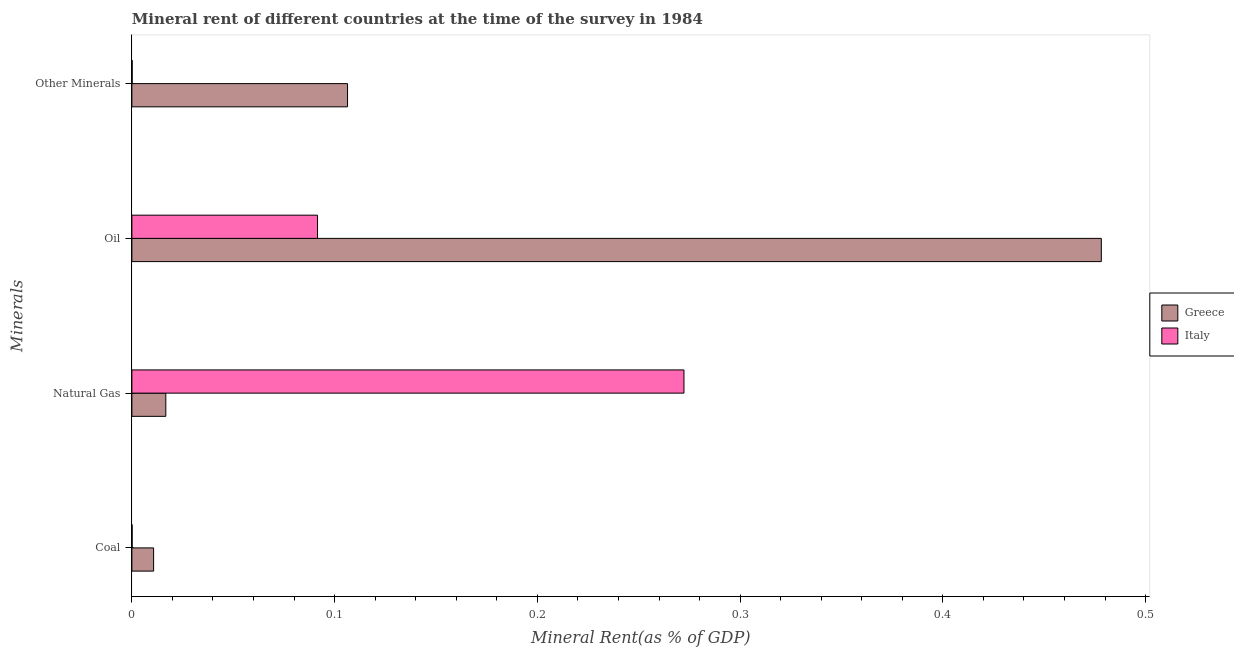How many different coloured bars are there?
Your response must be concise. 2. Are the number of bars per tick equal to the number of legend labels?
Your answer should be compact. Yes. Are the number of bars on each tick of the Y-axis equal?
Provide a short and direct response. Yes. How many bars are there on the 3rd tick from the bottom?
Your answer should be compact. 2. What is the label of the 1st group of bars from the top?
Offer a terse response. Other Minerals. What is the  rent of other minerals in Italy?
Provide a succinct answer. 0. Across all countries, what is the maximum oil rent?
Make the answer very short. 0.48. Across all countries, what is the minimum coal rent?
Your response must be concise. 0. In which country was the natural gas rent maximum?
Keep it short and to the point. Italy. What is the total oil rent in the graph?
Offer a very short reply. 0.57. What is the difference between the  rent of other minerals in Italy and that in Greece?
Offer a terse response. -0.11. What is the difference between the natural gas rent in Greece and the oil rent in Italy?
Your answer should be compact. -0.07. What is the average  rent of other minerals per country?
Provide a succinct answer. 0.05. What is the difference between the coal rent and  rent of other minerals in Italy?
Your answer should be very brief. -3.1037804786455015e-5. In how many countries, is the natural gas rent greater than 0.26 %?
Your answer should be very brief. 1. What is the ratio of the oil rent in Italy to that in Greece?
Provide a short and direct response. 0.19. Is the difference between the natural gas rent in Greece and Italy greater than the difference between the  rent of other minerals in Greece and Italy?
Offer a very short reply. No. What is the difference between the highest and the second highest coal rent?
Offer a terse response. 0.01. What is the difference between the highest and the lowest coal rent?
Offer a terse response. 0.01. Is the sum of the coal rent in Italy and Greece greater than the maximum oil rent across all countries?
Make the answer very short. No. What does the 1st bar from the top in Other Minerals represents?
Give a very brief answer. Italy. What does the 2nd bar from the bottom in Natural Gas represents?
Offer a terse response. Italy. Are all the bars in the graph horizontal?
Make the answer very short. Yes. How many countries are there in the graph?
Offer a very short reply. 2. Does the graph contain grids?
Your answer should be compact. No. How many legend labels are there?
Make the answer very short. 2. How are the legend labels stacked?
Make the answer very short. Vertical. What is the title of the graph?
Your response must be concise. Mineral rent of different countries at the time of the survey in 1984. Does "Mexico" appear as one of the legend labels in the graph?
Keep it short and to the point. No. What is the label or title of the X-axis?
Offer a very short reply. Mineral Rent(as % of GDP). What is the label or title of the Y-axis?
Offer a very short reply. Minerals. What is the Mineral Rent(as % of GDP) in Greece in Coal?
Keep it short and to the point. 0.01. What is the Mineral Rent(as % of GDP) in Italy in Coal?
Your answer should be very brief. 0. What is the Mineral Rent(as % of GDP) of Greece in Natural Gas?
Offer a terse response. 0.02. What is the Mineral Rent(as % of GDP) in Italy in Natural Gas?
Give a very brief answer. 0.27. What is the Mineral Rent(as % of GDP) of Greece in Oil?
Keep it short and to the point. 0.48. What is the Mineral Rent(as % of GDP) in Italy in Oil?
Offer a terse response. 0.09. What is the Mineral Rent(as % of GDP) of Greece in Other Minerals?
Offer a terse response. 0.11. What is the Mineral Rent(as % of GDP) in Italy in Other Minerals?
Provide a succinct answer. 0. Across all Minerals, what is the maximum Mineral Rent(as % of GDP) of Greece?
Ensure brevity in your answer.  0.48. Across all Minerals, what is the maximum Mineral Rent(as % of GDP) of Italy?
Your response must be concise. 0.27. Across all Minerals, what is the minimum Mineral Rent(as % of GDP) of Greece?
Your answer should be very brief. 0.01. Across all Minerals, what is the minimum Mineral Rent(as % of GDP) in Italy?
Keep it short and to the point. 0. What is the total Mineral Rent(as % of GDP) in Greece in the graph?
Offer a very short reply. 0.61. What is the total Mineral Rent(as % of GDP) of Italy in the graph?
Keep it short and to the point. 0.36. What is the difference between the Mineral Rent(as % of GDP) of Greece in Coal and that in Natural Gas?
Ensure brevity in your answer.  -0.01. What is the difference between the Mineral Rent(as % of GDP) in Italy in Coal and that in Natural Gas?
Your answer should be very brief. -0.27. What is the difference between the Mineral Rent(as % of GDP) in Greece in Coal and that in Oil?
Your answer should be very brief. -0.47. What is the difference between the Mineral Rent(as % of GDP) of Italy in Coal and that in Oil?
Your answer should be very brief. -0.09. What is the difference between the Mineral Rent(as % of GDP) of Greece in Coal and that in Other Minerals?
Your answer should be compact. -0.1. What is the difference between the Mineral Rent(as % of GDP) in Greece in Natural Gas and that in Oil?
Provide a short and direct response. -0.46. What is the difference between the Mineral Rent(as % of GDP) of Italy in Natural Gas and that in Oil?
Provide a succinct answer. 0.18. What is the difference between the Mineral Rent(as % of GDP) of Greece in Natural Gas and that in Other Minerals?
Your answer should be very brief. -0.09. What is the difference between the Mineral Rent(as % of GDP) of Italy in Natural Gas and that in Other Minerals?
Give a very brief answer. 0.27. What is the difference between the Mineral Rent(as % of GDP) of Greece in Oil and that in Other Minerals?
Offer a very short reply. 0.37. What is the difference between the Mineral Rent(as % of GDP) of Italy in Oil and that in Other Minerals?
Offer a terse response. 0.09. What is the difference between the Mineral Rent(as % of GDP) in Greece in Coal and the Mineral Rent(as % of GDP) in Italy in Natural Gas?
Provide a short and direct response. -0.26. What is the difference between the Mineral Rent(as % of GDP) in Greece in Coal and the Mineral Rent(as % of GDP) in Italy in Oil?
Ensure brevity in your answer.  -0.08. What is the difference between the Mineral Rent(as % of GDP) in Greece in Coal and the Mineral Rent(as % of GDP) in Italy in Other Minerals?
Provide a short and direct response. 0.01. What is the difference between the Mineral Rent(as % of GDP) in Greece in Natural Gas and the Mineral Rent(as % of GDP) in Italy in Oil?
Your answer should be compact. -0.07. What is the difference between the Mineral Rent(as % of GDP) in Greece in Natural Gas and the Mineral Rent(as % of GDP) in Italy in Other Minerals?
Provide a short and direct response. 0.02. What is the difference between the Mineral Rent(as % of GDP) of Greece in Oil and the Mineral Rent(as % of GDP) of Italy in Other Minerals?
Offer a very short reply. 0.48. What is the average Mineral Rent(as % of GDP) of Greece per Minerals?
Keep it short and to the point. 0.15. What is the average Mineral Rent(as % of GDP) of Italy per Minerals?
Your answer should be compact. 0.09. What is the difference between the Mineral Rent(as % of GDP) of Greece and Mineral Rent(as % of GDP) of Italy in Coal?
Make the answer very short. 0.01. What is the difference between the Mineral Rent(as % of GDP) in Greece and Mineral Rent(as % of GDP) in Italy in Natural Gas?
Make the answer very short. -0.26. What is the difference between the Mineral Rent(as % of GDP) of Greece and Mineral Rent(as % of GDP) of Italy in Oil?
Make the answer very short. 0.39. What is the difference between the Mineral Rent(as % of GDP) in Greece and Mineral Rent(as % of GDP) in Italy in Other Minerals?
Give a very brief answer. 0.11. What is the ratio of the Mineral Rent(as % of GDP) of Greece in Coal to that in Natural Gas?
Offer a terse response. 0.64. What is the ratio of the Mineral Rent(as % of GDP) of Greece in Coal to that in Oil?
Give a very brief answer. 0.02. What is the ratio of the Mineral Rent(as % of GDP) of Italy in Coal to that in Oil?
Offer a very short reply. 0. What is the ratio of the Mineral Rent(as % of GDP) in Greece in Coal to that in Other Minerals?
Your answer should be very brief. 0.1. What is the ratio of the Mineral Rent(as % of GDP) in Italy in Coal to that in Other Minerals?
Offer a very short reply. 0.8. What is the ratio of the Mineral Rent(as % of GDP) in Greece in Natural Gas to that in Oil?
Your answer should be very brief. 0.04. What is the ratio of the Mineral Rent(as % of GDP) in Italy in Natural Gas to that in Oil?
Your response must be concise. 2.97. What is the ratio of the Mineral Rent(as % of GDP) in Greece in Natural Gas to that in Other Minerals?
Your answer should be compact. 0.16. What is the ratio of the Mineral Rent(as % of GDP) of Italy in Natural Gas to that in Other Minerals?
Ensure brevity in your answer.  1777.57. What is the ratio of the Mineral Rent(as % of GDP) in Greece in Oil to that in Other Minerals?
Make the answer very short. 4.5. What is the ratio of the Mineral Rent(as % of GDP) in Italy in Oil to that in Other Minerals?
Keep it short and to the point. 597.78. What is the difference between the highest and the second highest Mineral Rent(as % of GDP) in Greece?
Keep it short and to the point. 0.37. What is the difference between the highest and the second highest Mineral Rent(as % of GDP) of Italy?
Your response must be concise. 0.18. What is the difference between the highest and the lowest Mineral Rent(as % of GDP) in Greece?
Your answer should be compact. 0.47. What is the difference between the highest and the lowest Mineral Rent(as % of GDP) in Italy?
Offer a very short reply. 0.27. 